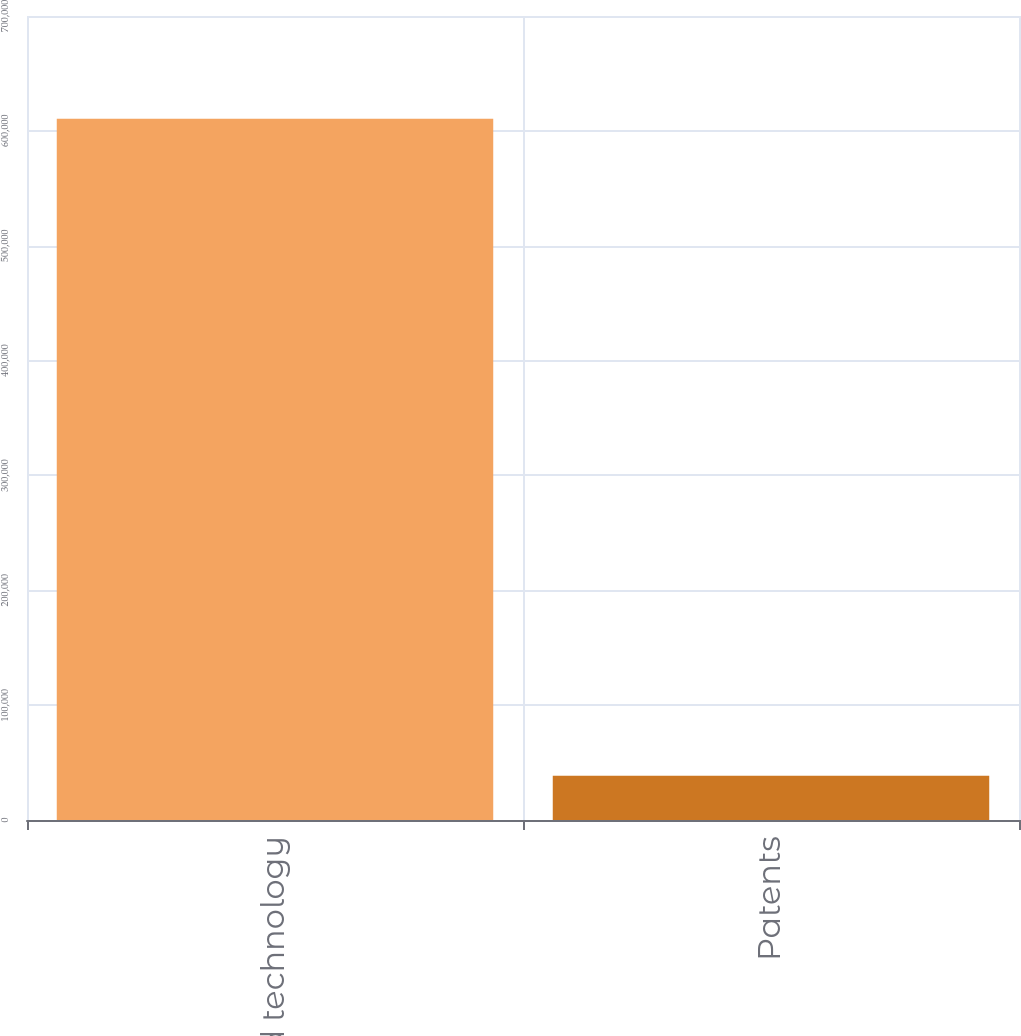Convert chart to OTSL. <chart><loc_0><loc_0><loc_500><loc_500><bar_chart><fcel>Developed technology<fcel>Patents<nl><fcel>610512<fcel>38438<nl></chart> 